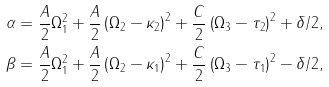Convert formula to latex. <formula><loc_0><loc_0><loc_500><loc_500>\alpha & = \frac { A } { 2 } \Omega _ { 1 } ^ { 2 } + \frac { A } { 2 } \left ( \Omega _ { 2 } - \kappa _ { 2 } \right ) ^ { 2 } + \frac { C } { 2 } \left ( \Omega _ { 3 } - \tau _ { 2 } \right ) ^ { 2 } + \delta / 2 , \\ \beta & = \frac { A } { 2 } \Omega _ { 1 } ^ { 2 } + \frac { A } { 2 } \left ( \Omega _ { 2 } - \kappa _ { 1 } \right ) ^ { 2 } + \frac { C } { 2 } \left ( \Omega _ { 3 } - \tau _ { 1 } \right ) ^ { 2 } - \delta / 2 ,</formula> 